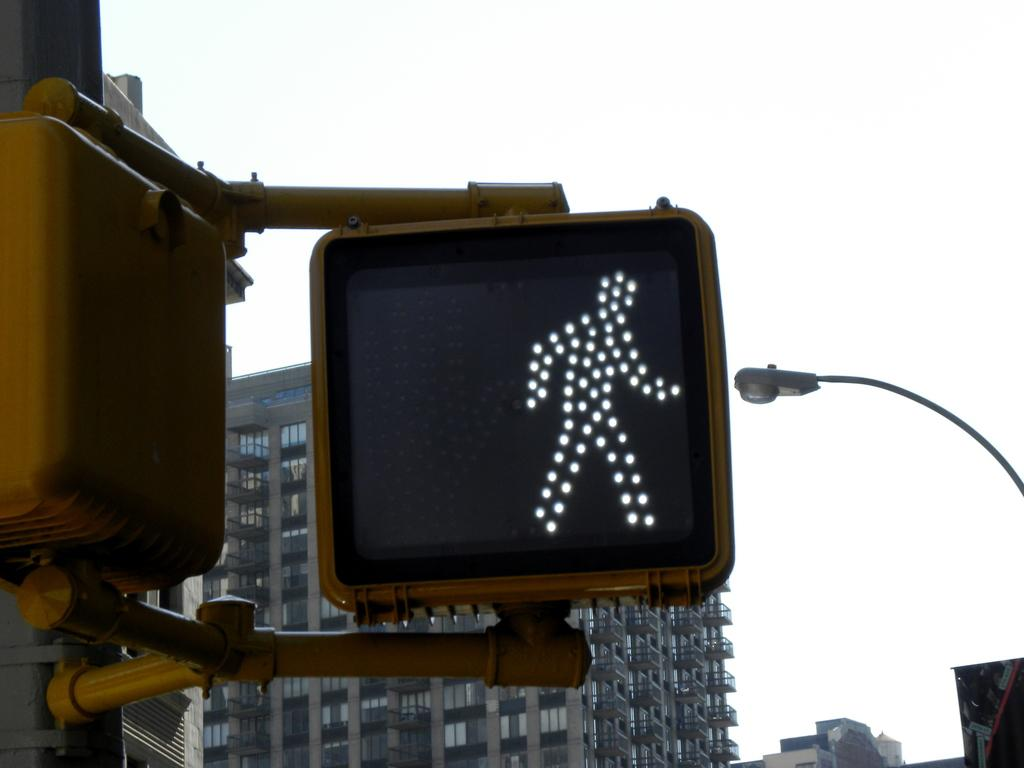What is the main subject of the image? The main subject of the image is a traffic signal. What can be seen in the background of the image? There are buildings visible in the background of the image. How does the traffic signal join with the zinc in the image? There is no zinc present in the image, and the traffic signal is not connected to any zinc. 